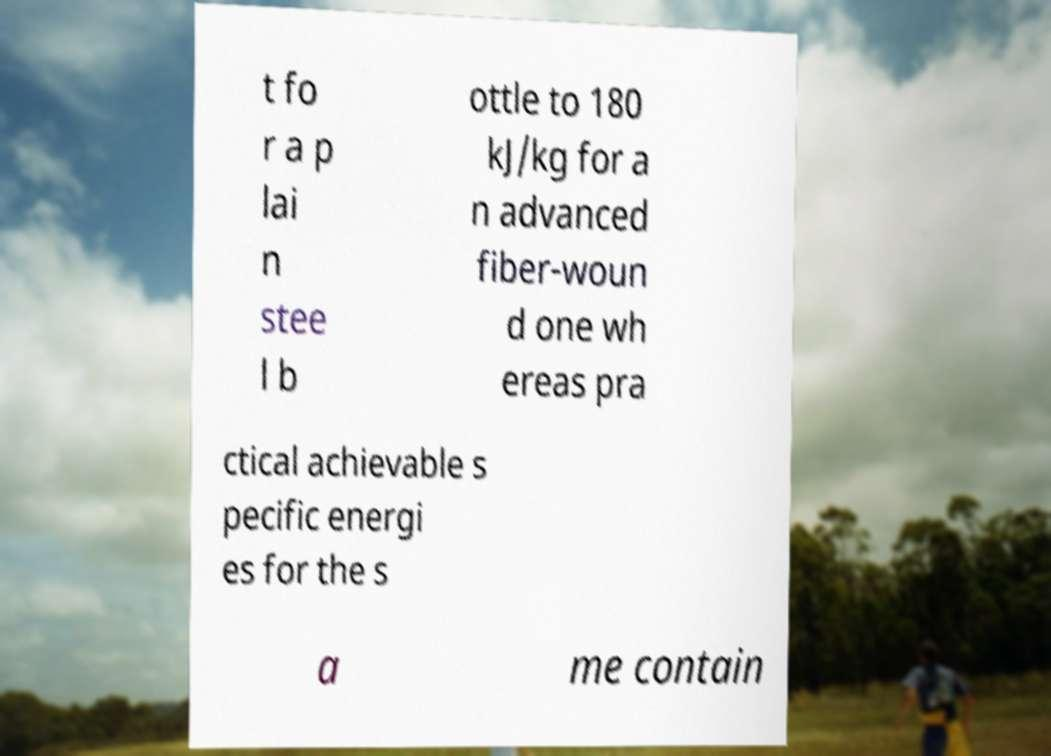There's text embedded in this image that I need extracted. Can you transcribe it verbatim? t fo r a p lai n stee l b ottle to 180 kJ/kg for a n advanced fiber-woun d one wh ereas pra ctical achievable s pecific energi es for the s a me contain 